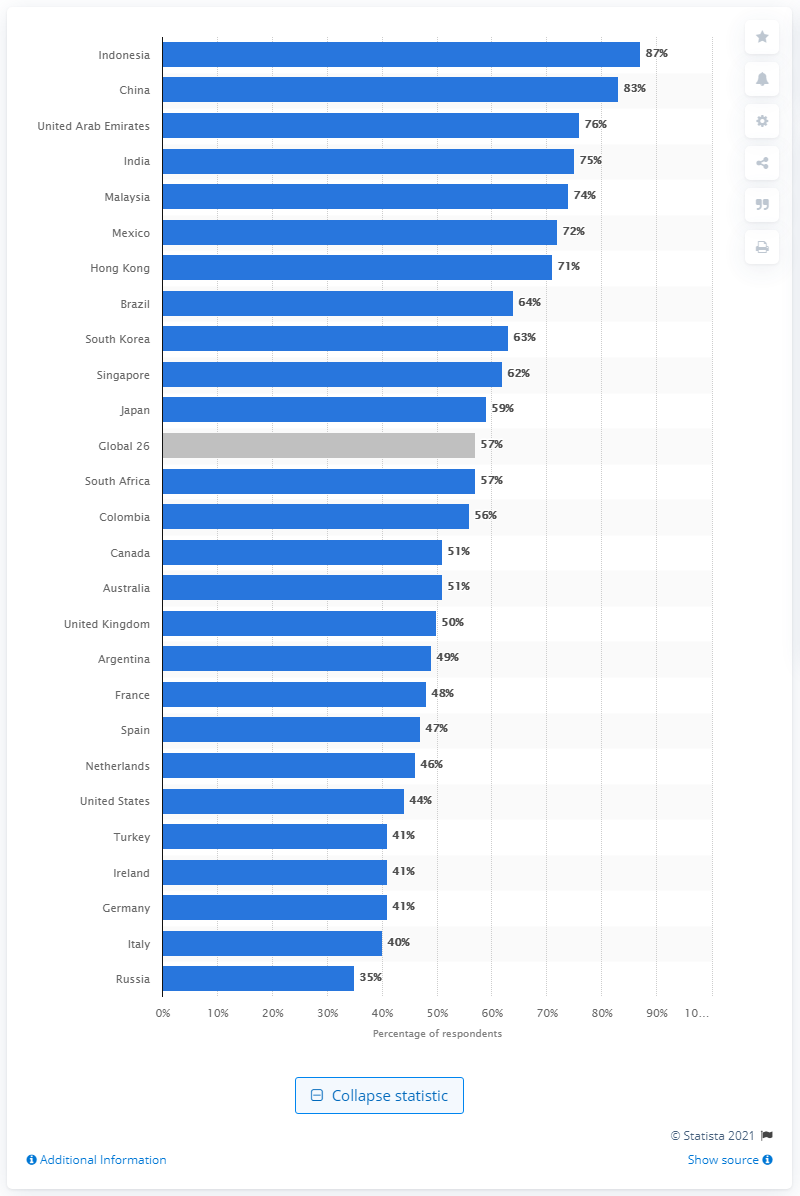Outline some significant characteristics in this image. According to a recent survey, Indonesia had the highest trust level towards the pharma sector among all countries surveyed. In 2019, the level of trust towards the pharma sector in Indonesia was 87%. 